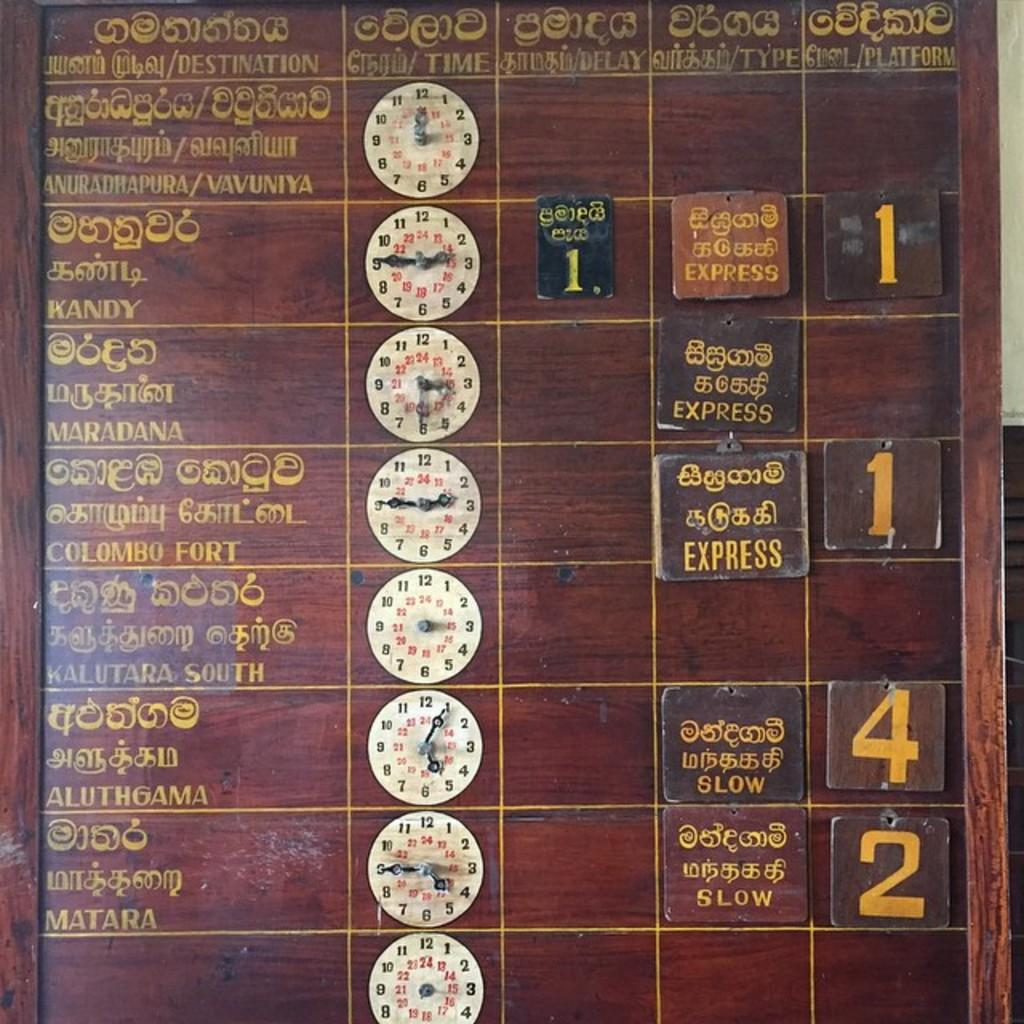<image>
Present a compact description of the photo's key features. Board showing different languages and the number 4 oni t. 